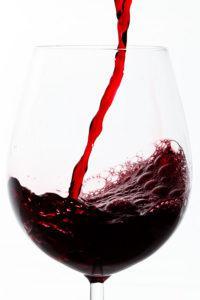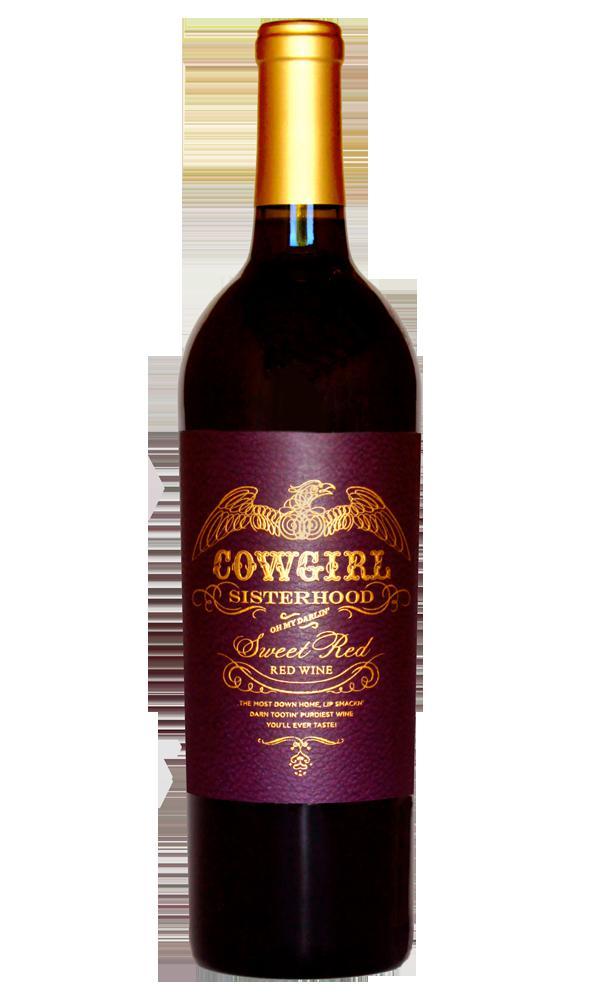The first image is the image on the left, the second image is the image on the right. Examine the images to the left and right. Is the description "At least one of the images shows a sealed bottle of wine." accurate? Answer yes or no. Yes. 